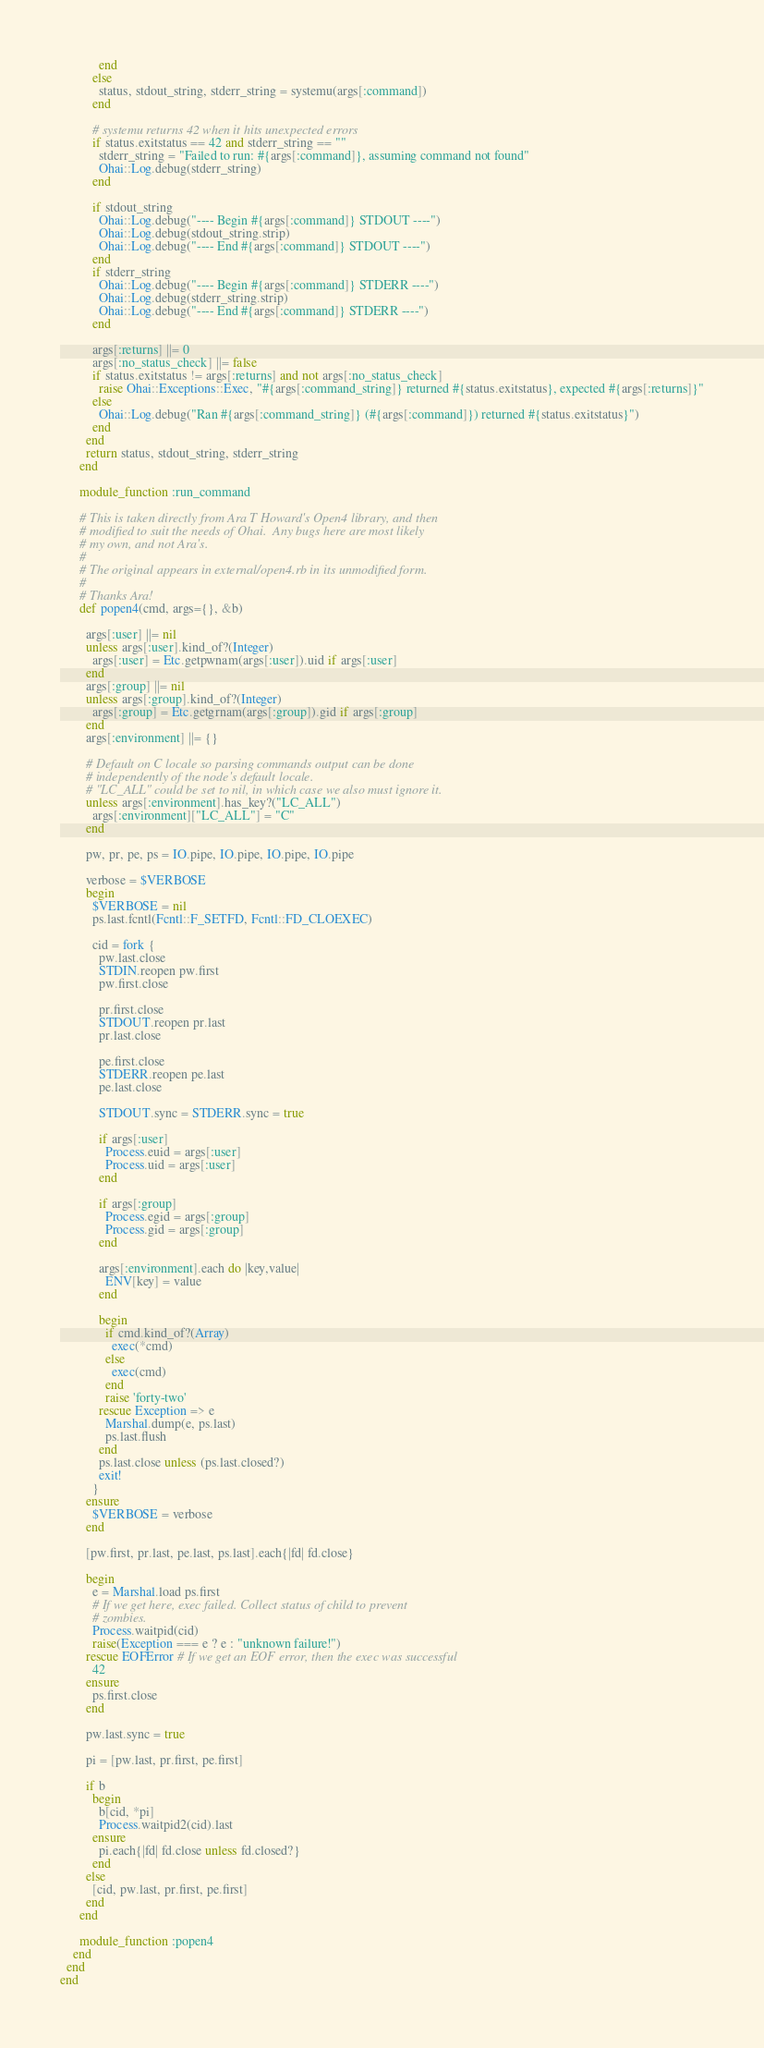<code> <loc_0><loc_0><loc_500><loc_500><_Ruby_>            end
          else
            status, stdout_string, stderr_string = systemu(args[:command])
          end

          # systemu returns 42 when it hits unexpected errors
          if status.exitstatus == 42 and stderr_string == ""
            stderr_string = "Failed to run: #{args[:command]}, assuming command not found"
            Ohai::Log.debug(stderr_string)          
          end

          if stdout_string
            Ohai::Log.debug("---- Begin #{args[:command]} STDOUT ----")
            Ohai::Log.debug(stdout_string.strip)
            Ohai::Log.debug("---- End #{args[:command]} STDOUT ----")
          end
          if stderr_string
            Ohai::Log.debug("---- Begin #{args[:command]} STDERR ----")
            Ohai::Log.debug(stderr_string.strip)
            Ohai::Log.debug("---- End #{args[:command]} STDERR ----")
          end
        
          args[:returns] ||= 0
          args[:no_status_check] ||= false
          if status.exitstatus != args[:returns] and not args[:no_status_check]
            raise Ohai::Exceptions::Exec, "#{args[:command_string]} returned #{status.exitstatus}, expected #{args[:returns]}"
          else
            Ohai::Log.debug("Ran #{args[:command_string]} (#{args[:command]}) returned #{status.exitstatus}")
          end
        end
        return status, stdout_string, stderr_string
      end

      module_function :run_command
           
      # This is taken directly from Ara T Howard's Open4 library, and then 
      # modified to suit the needs of Ohai.  Any bugs here are most likely
      # my own, and not Ara's.
      #
      # The original appears in external/open4.rb in its unmodified form. 
      #
      # Thanks Ara!
      def popen4(cmd, args={}, &b)
        
        args[:user] ||= nil
        unless args[:user].kind_of?(Integer)
          args[:user] = Etc.getpwnam(args[:user]).uid if args[:user]
        end
        args[:group] ||= nil
        unless args[:group].kind_of?(Integer)
          args[:group] = Etc.getgrnam(args[:group]).gid if args[:group]
        end
        args[:environment] ||= {}

        # Default on C locale so parsing commands output can be done
        # independently of the node's default locale.
        # "LC_ALL" could be set to nil, in which case we also must ignore it.
        unless args[:environment].has_key?("LC_ALL")
          args[:environment]["LC_ALL"] = "C"
        end
        
        pw, pr, pe, ps = IO.pipe, IO.pipe, IO.pipe, IO.pipe

        verbose = $VERBOSE
        begin
          $VERBOSE = nil
          ps.last.fcntl(Fcntl::F_SETFD, Fcntl::FD_CLOEXEC)

          cid = fork {
            pw.last.close
            STDIN.reopen pw.first
            pw.first.close

            pr.first.close
            STDOUT.reopen pr.last
            pr.last.close

            pe.first.close
            STDERR.reopen pe.last
            pe.last.close

            STDOUT.sync = STDERR.sync = true

            if args[:user]
              Process.euid = args[:user]
              Process.uid = args[:user]
            end
            
            if args[:group]
              Process.egid = args[:group]
              Process.gid = args[:group]
            end
            
            args[:environment].each do |key,value|
              ENV[key] = value
            end
            
            begin
              if cmd.kind_of?(Array)
                exec(*cmd)
              else
                exec(cmd)
              end
              raise 'forty-two' 
            rescue Exception => e
              Marshal.dump(e, ps.last)
              ps.last.flush
            end
            ps.last.close unless (ps.last.closed?)
            exit!
          }
        ensure
          $VERBOSE = verbose
        end

        [pw.first, pr.last, pe.last, ps.last].each{|fd| fd.close}

        begin
          e = Marshal.load ps.first
          # If we get here, exec failed. Collect status of child to prevent
          # zombies.
          Process.waitpid(cid)
          raise(Exception === e ? e : "unknown failure!")
        rescue EOFError # If we get an EOF error, then the exec was successful
          42
        ensure
          ps.first.close
        end

        pw.last.sync = true

        pi = [pw.last, pr.first, pe.first]

        if b 
          begin
            b[cid, *pi]
            Process.waitpid2(cid).last
          ensure
            pi.each{|fd| fd.close unless fd.closed?}
          end
        else
          [cid, pw.last, pr.first, pe.first]
        end
      end      
      
      module_function :popen4
    end
  end
end
</code> 